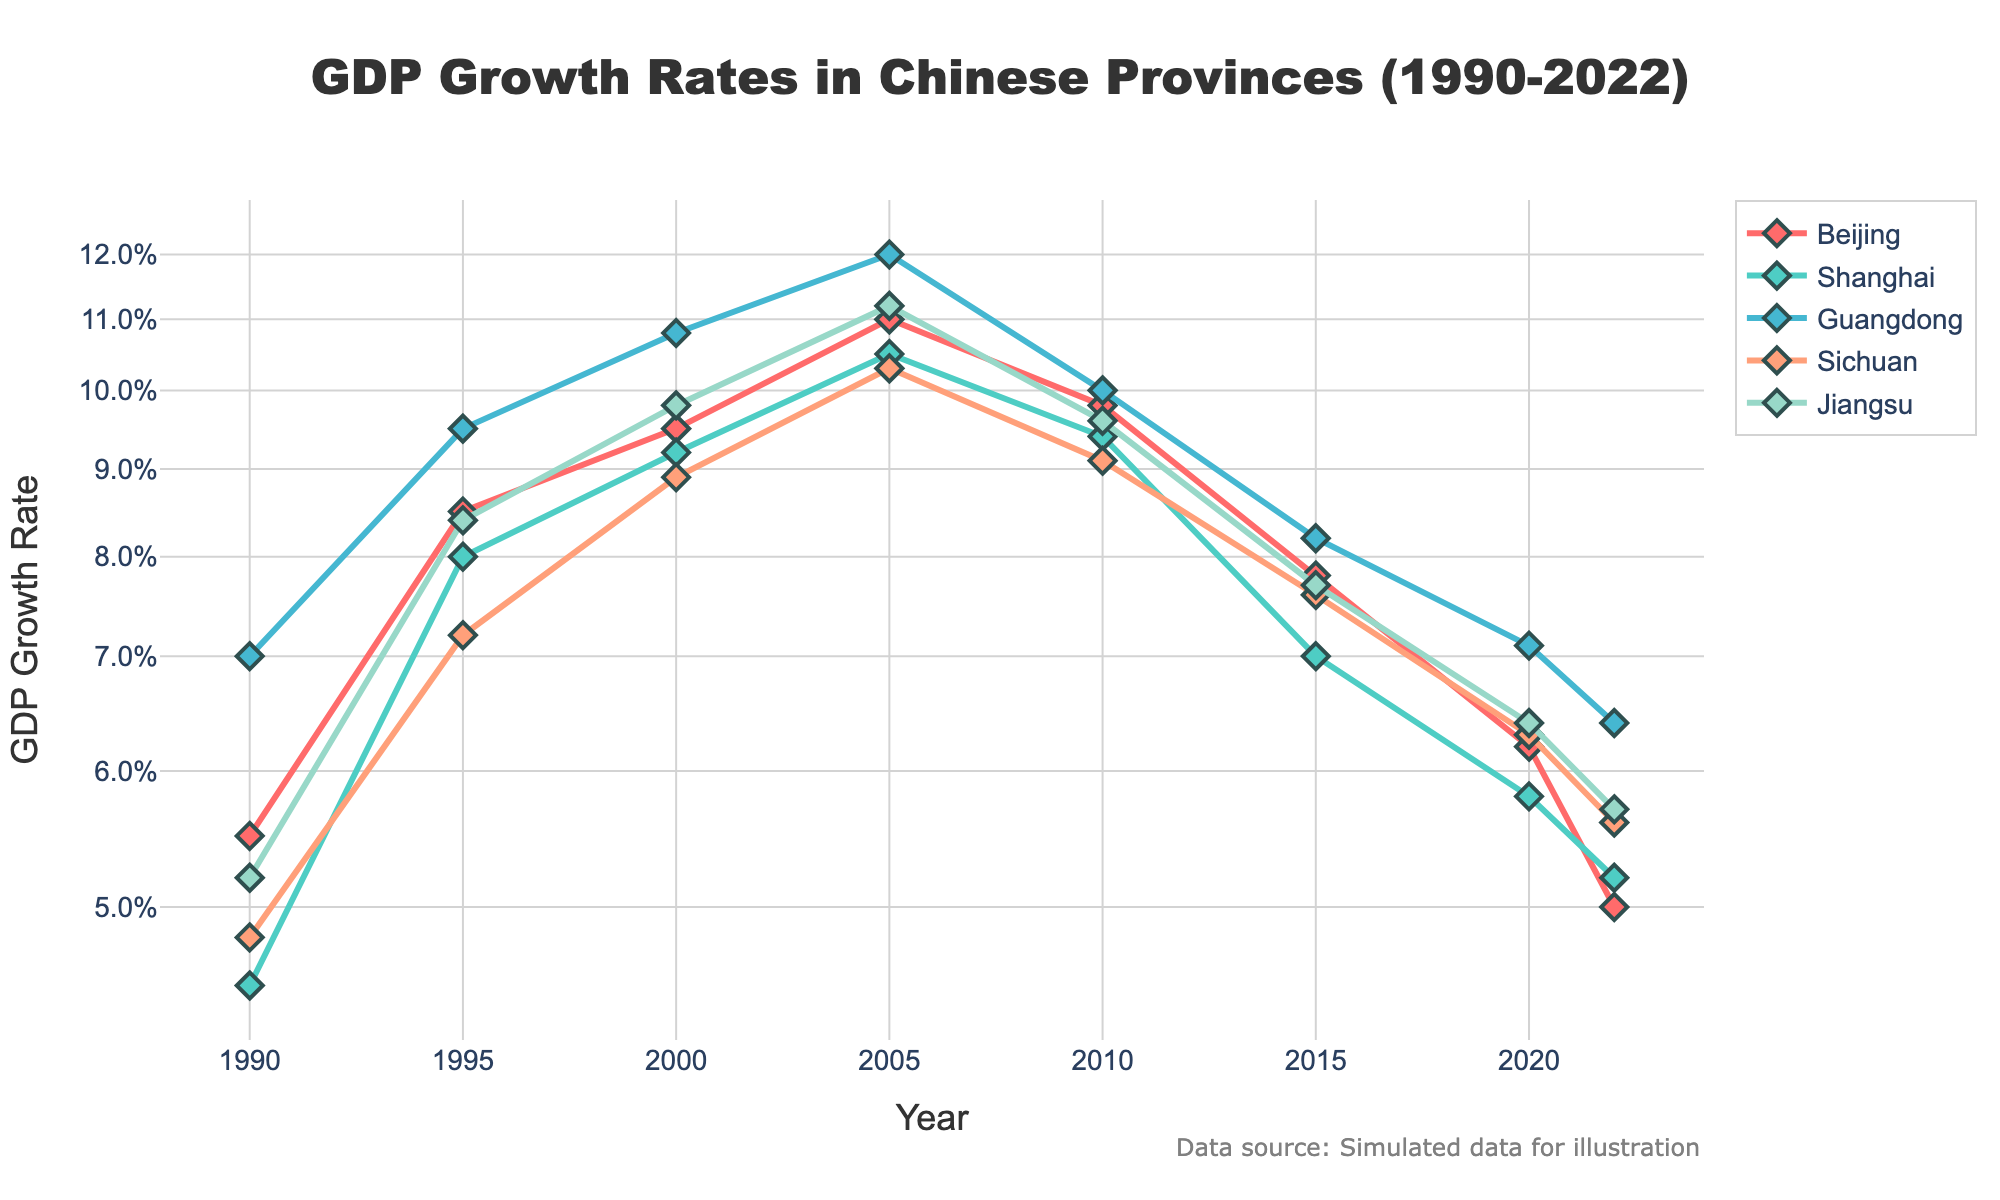What is the title of the figure? The title is located at the top center of the plot and is usually in larger font. It clearly describes the content of the figure related to GDP growth rates in Chinese provinces from 1990 to 2022.
Answer: GDP Growth Rates in Chinese Provinces (1990-2022) Which province had the highest GDP growth rate in the year 2005? To determine this, visually follow the x-axis to the year 2005 and see which province has the highest point along the y-axis for that year.
Answer: Guangdong What trend can be observed in Beijing's GDP growth rate from 1990 to 2022? Observe the line corresponding to Beijing over the years intervals from 1990 to 2022, and note whether it trends upwards, downwards, or stays constant. Beijing's growth rate starts at a higher value and gradually decreases.
Answer: Decreasing trend How does Shanghai's GDP growth rate in 2010 compare to that in 1990? Locate Shanghai's data points for 1990 and 2010. Compare the y-values (GDP growth rates) to identify which is higher and note the difference in logarithmic scale if needed.
Answer: Higher in 2010 What is the average GDP growth rate of Jiangsu over the years listed? Sum Jiangsu's GDP growth rates from each listed year and divide by the number of years – (0.052 + 0.084 + 0.098 + 0.112 + 0.096 + 0.077 + 0.064 + 0.057) / 8. Calculate the mean using these values.
Answer: 0.080 Which province shows the most variability in GDP growth rates over the period? Look at the fluctuation of the lines for each province. The province with the greatest amplitude of ups and downs on the graph will have the most variability.
Answer: Guangdong What is the GDP growth rate for Beijing in 2022, and how does it compare to its rate in 2000? Identify Beijing's GDP growth rate at 2022 and 2000 on the chart. Compare these two values directly.
Answer: 2022: 0.050, 2000: 0.095, Decrease Which province had a noticeable dip in GDP growth rate around 2015? Observe the chart and note which line dips significantly around the year 2015.
Answer: Shanghai Between Sichuan and Jiangsu, which province had higher GDP growth rates on average from 1990 to 2022? Calculate the average GDP growth rate for Sichuan and Jiangsu separately by summing their yearly growth rates and dividing by the number of years for each. Compare these two averages.
Answer: Jiangsu How does the GDP growth rate trend of Guangdong compare to that of Sichuan over the years? Observe the lines for both Guangdong and Sichuan across the years and describe the general trend of each. Guangdong shows a more consistent downward trend while Sichuan shows occasional dips.
Answer: Guangdong: consistent decrease, Sichuan: fluctuating but decreasing 